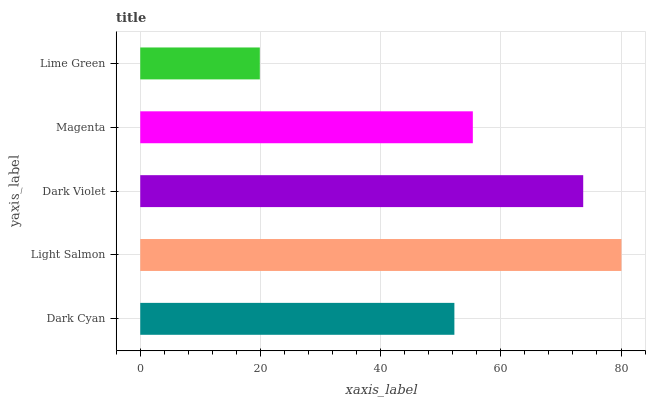Is Lime Green the minimum?
Answer yes or no. Yes. Is Light Salmon the maximum?
Answer yes or no. Yes. Is Dark Violet the minimum?
Answer yes or no. No. Is Dark Violet the maximum?
Answer yes or no. No. Is Light Salmon greater than Dark Violet?
Answer yes or no. Yes. Is Dark Violet less than Light Salmon?
Answer yes or no. Yes. Is Dark Violet greater than Light Salmon?
Answer yes or no. No. Is Light Salmon less than Dark Violet?
Answer yes or no. No. Is Magenta the high median?
Answer yes or no. Yes. Is Magenta the low median?
Answer yes or no. Yes. Is Dark Violet the high median?
Answer yes or no. No. Is Dark Cyan the low median?
Answer yes or no. No. 